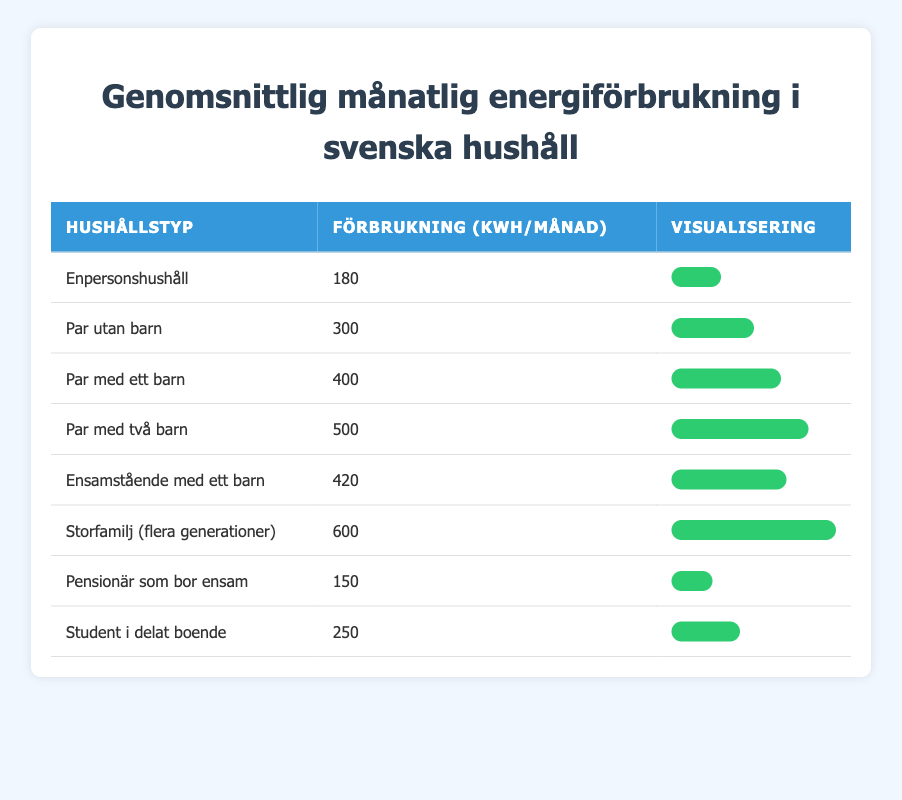What is the monthly energy consumption for a single-parent family with one child? The table lists "Single-parent family with one child" and their corresponding monthly consumption, which is 420 kWh.
Answer: 420 kWh Which household type has the highest energy consumption? In the table, the "Extended family (multi-generational)" is noted with the highest value of 600 kWh.
Answer: Extended family (multi-generational) What is the average monthly energy consumption for couples with children? To find the average, we calculate for the household types "Couple with one child" (400 kWh) and "Couple with two children" (500 kWh). The sum is 400 + 500 = 900 kWh, and there are 2 households, so 900 / 2 = 450 kWh.
Answer: 450 kWh Is the monthly energy consumption for a couple without children greater than that for a student living in shared accommodation? "Couple without children" has 300 kWh and "Student living in shared accommodation" has 250 kWh. Since 300 kWh is greater than 250 kWh, the answer is yes.
Answer: Yes What is the difference in energy consumption between a senior citizen living alone and a couple with two children? The senior citizen living alone consumes 150 kWh, while a couple with two children consumes 500 kWh. The difference is 500 - 150 = 350 kWh.
Answer: 350 kWh 